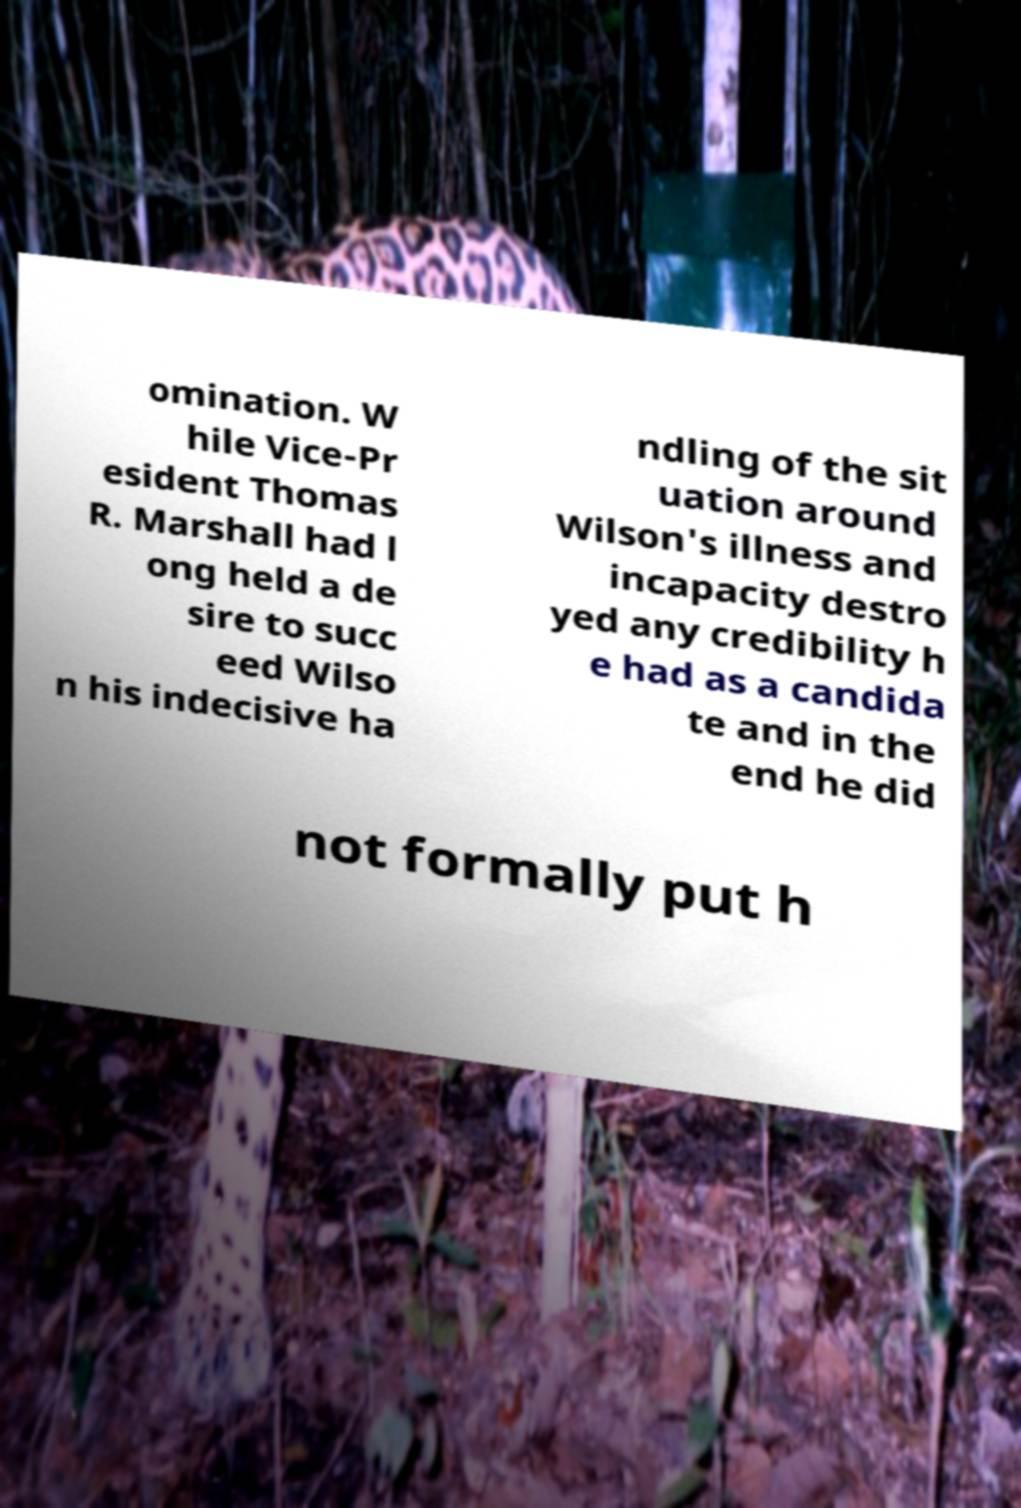I need the written content from this picture converted into text. Can you do that? omination. W hile Vice-Pr esident Thomas R. Marshall had l ong held a de sire to succ eed Wilso n his indecisive ha ndling of the sit uation around Wilson's illness and incapacity destro yed any credibility h e had as a candida te and in the end he did not formally put h 